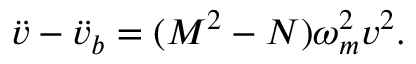Convert formula to latex. <formula><loc_0><loc_0><loc_500><loc_500>\ddot { v } - \ddot { v } _ { b } = ( M ^ { 2 } - N ) \omega _ { m } ^ { 2 } v ^ { 2 } .</formula> 